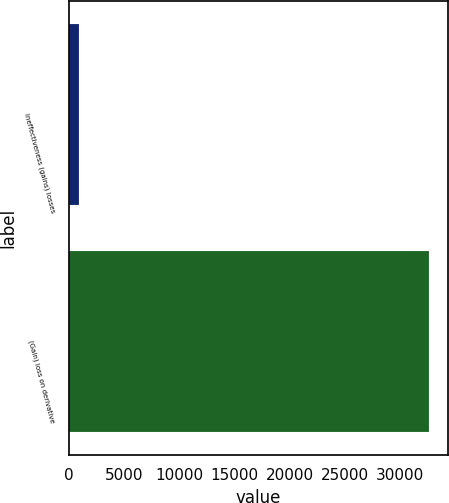Convert chart. <chart><loc_0><loc_0><loc_500><loc_500><bar_chart><fcel>Ineffectiveness (gains) losses<fcel>(Gain) loss on derivative<nl><fcel>930<fcel>32680<nl></chart> 